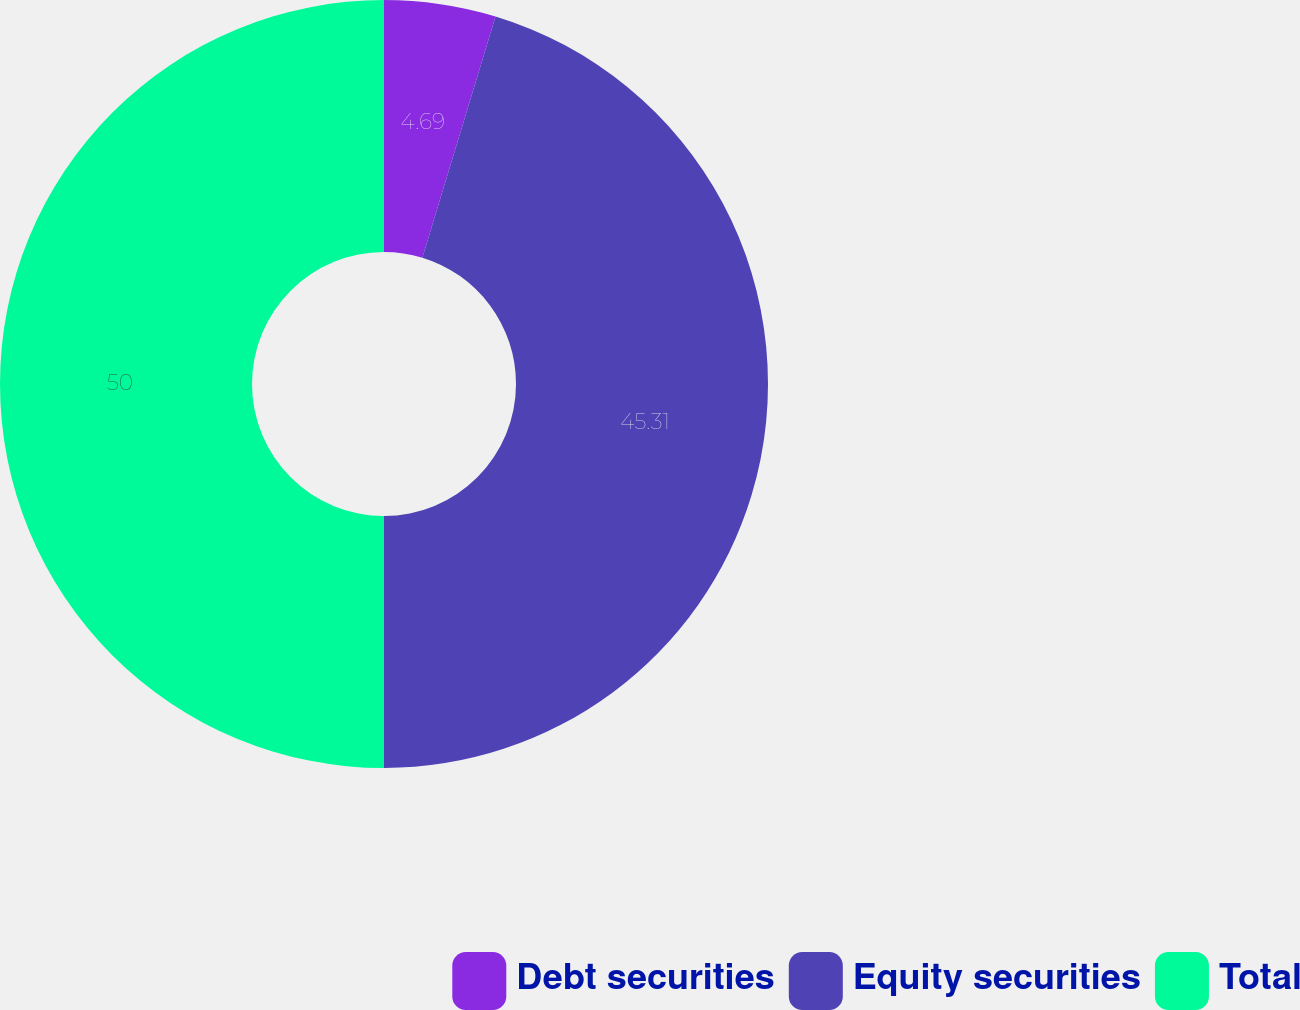Convert chart to OTSL. <chart><loc_0><loc_0><loc_500><loc_500><pie_chart><fcel>Debt securities<fcel>Equity securities<fcel>Total<nl><fcel>4.69%<fcel>45.31%<fcel>50.0%<nl></chart> 